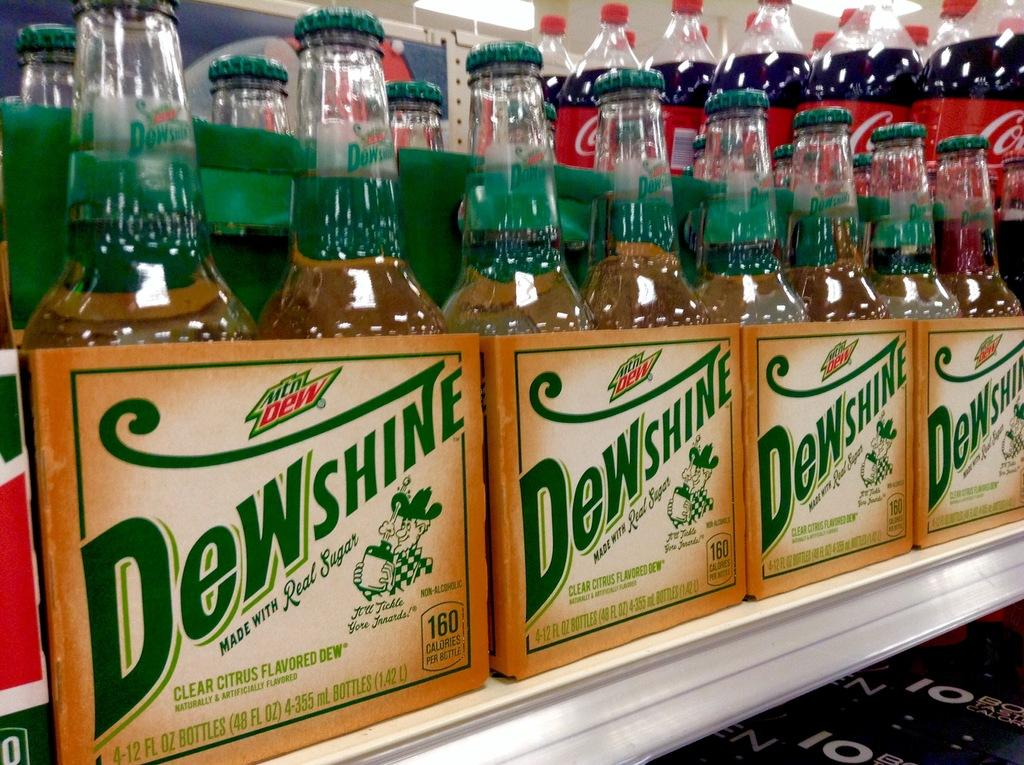<image>
Provide a brief description of the given image. Several cases of DewShine sit next to each other on a shelf. 